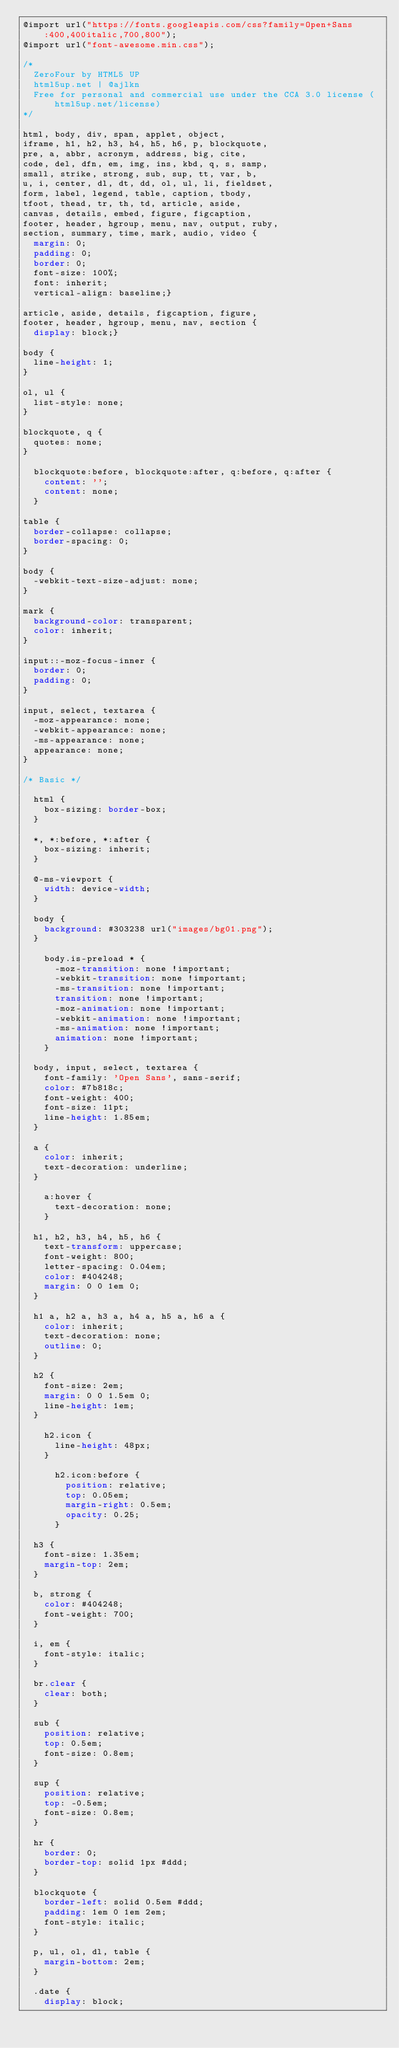<code> <loc_0><loc_0><loc_500><loc_500><_CSS_>@import url("https://fonts.googleapis.com/css?family=Open+Sans:400,400italic,700,800");
@import url("font-awesome.min.css");

/*
	ZeroFour by HTML5 UP
	html5up.net | @ajlkn
	Free for personal and commercial use under the CCA 3.0 license (html5up.net/license)
*/

html, body, div, span, applet, object,
iframe, h1, h2, h3, h4, h5, h6, p, blockquote,
pre, a, abbr, acronym, address, big, cite,
code, del, dfn, em, img, ins, kbd, q, s, samp,
small, strike, strong, sub, sup, tt, var, b,
u, i, center, dl, dt, dd, ol, ul, li, fieldset,
form, label, legend, table, caption, tbody,
tfoot, thead, tr, th, td, article, aside,
canvas, details, embed, figure, figcaption,
footer, header, hgroup, menu, nav, output, ruby,
section, summary, time, mark, audio, video {
	margin: 0;
	padding: 0;
	border: 0;
	font-size: 100%;
	font: inherit;
	vertical-align: baseline;}

article, aside, details, figcaption, figure,
footer, header, hgroup, menu, nav, section {
	display: block;}

body {
	line-height: 1;
}

ol, ul {
	list-style: none;
}

blockquote, q {
	quotes: none;
}

	blockquote:before, blockquote:after, q:before, q:after {
		content: '';
		content: none;
	}

table {
	border-collapse: collapse;
	border-spacing: 0;
}

body {
	-webkit-text-size-adjust: none;
}

mark {
	background-color: transparent;
	color: inherit;
}

input::-moz-focus-inner {
	border: 0;
	padding: 0;
}

input, select, textarea {
	-moz-appearance: none;
	-webkit-appearance: none;
	-ms-appearance: none;
	appearance: none;
}

/* Basic */

	html {
		box-sizing: border-box;
	}

	*, *:before, *:after {
		box-sizing: inherit;
	}

	@-ms-viewport {
		width: device-width;
	}

	body {
		background: #303238 url("images/bg01.png");
	}

		body.is-preload * {
			-moz-transition: none !important;
			-webkit-transition: none !important;
			-ms-transition: none !important;
			transition: none !important;
			-moz-animation: none !important;
			-webkit-animation: none !important;
			-ms-animation: none !important;
			animation: none !important;
		}

	body, input, select, textarea {
		font-family: 'Open Sans', sans-serif;
		color: #7b818c;
		font-weight: 400;
		font-size: 11pt;
		line-height: 1.85em;
	}

	a {
		color: inherit;
		text-decoration: underline;
	}

		a:hover {
			text-decoration: none;
		}

	h1, h2, h3, h4, h5, h6 {
		text-transform: uppercase;
		font-weight: 800;
		letter-spacing: 0.04em;
		color: #404248;
		margin: 0 0 1em 0;
	}

	h1 a, h2 a, h3 a, h4 a, h5 a, h6 a {
		color: inherit;
		text-decoration: none;
		outline: 0;
	}

	h2 {
		font-size: 2em;
		margin: 0 0 1.5em 0;
		line-height: 1em;
	}

		h2.icon {
			line-height: 48px;
		}

			h2.icon:before {
				position: relative;
				top: 0.05em;
				margin-right: 0.5em;
				opacity: 0.25;
			}

	h3 {
		font-size: 1.35em;
		margin-top: 2em;
	}

	b, strong {
		color: #404248;
		font-weight: 700;
	}

	i, em {
		font-style: italic;
	}

	br.clear {
		clear: both;
	}

	sub {
		position: relative;
		top: 0.5em;
		font-size: 0.8em;
	}

	sup {
		position: relative;
		top: -0.5em;
		font-size: 0.8em;
	}

	hr {
		border: 0;
		border-top: solid 1px #ddd;
	}

	blockquote {
		border-left: solid 0.5em #ddd;
		padding: 1em 0 1em 2em;
		font-style: italic;
	}

	p, ul, ol, dl, table {
		margin-bottom: 2em;
	}

	.date {
		display: block;</code> 